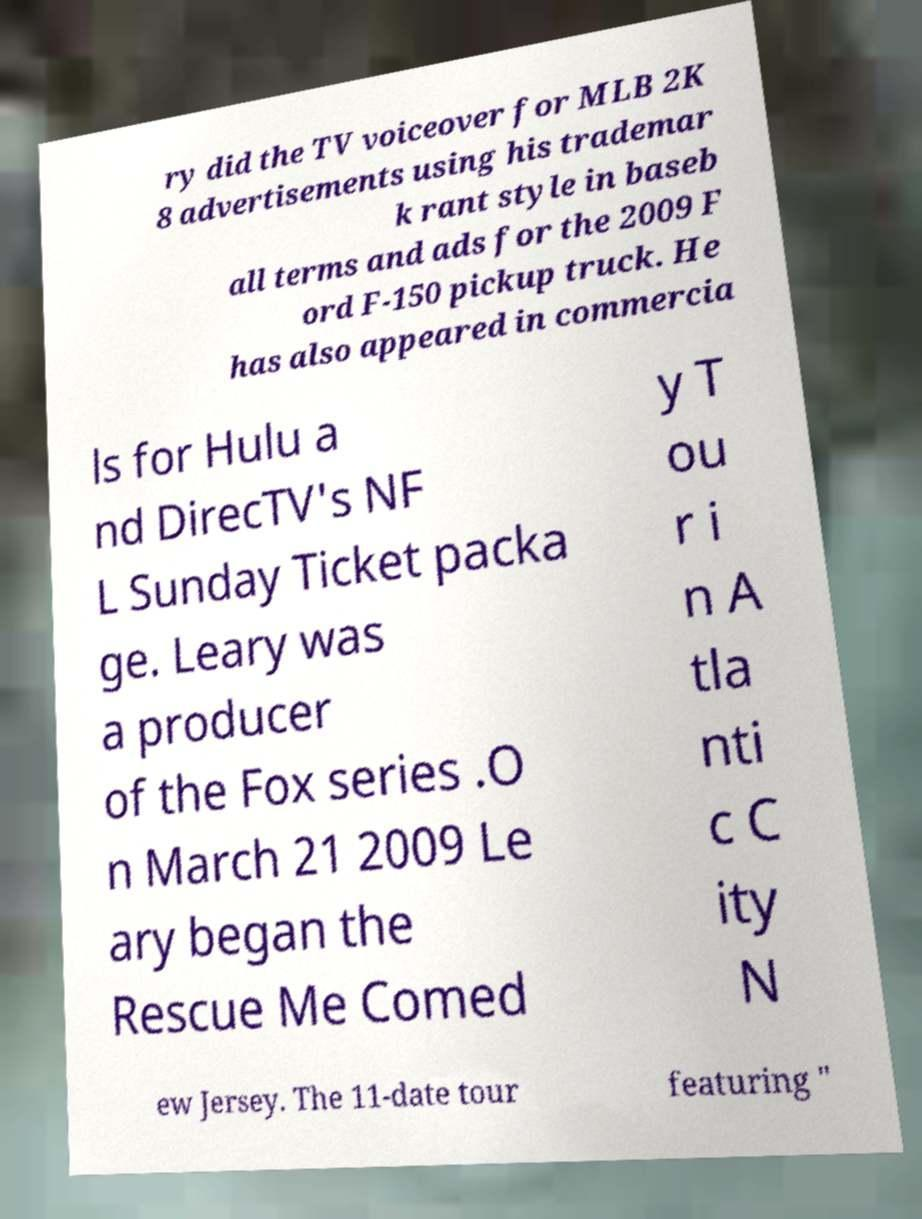Please read and relay the text visible in this image. What does it say? ry did the TV voiceover for MLB 2K 8 advertisements using his trademar k rant style in baseb all terms and ads for the 2009 F ord F-150 pickup truck. He has also appeared in commercia ls for Hulu a nd DirecTV's NF L Sunday Ticket packa ge. Leary was a producer of the Fox series .O n March 21 2009 Le ary began the Rescue Me Comed y T ou r i n A tla nti c C ity N ew Jersey. The 11-date tour featuring " 